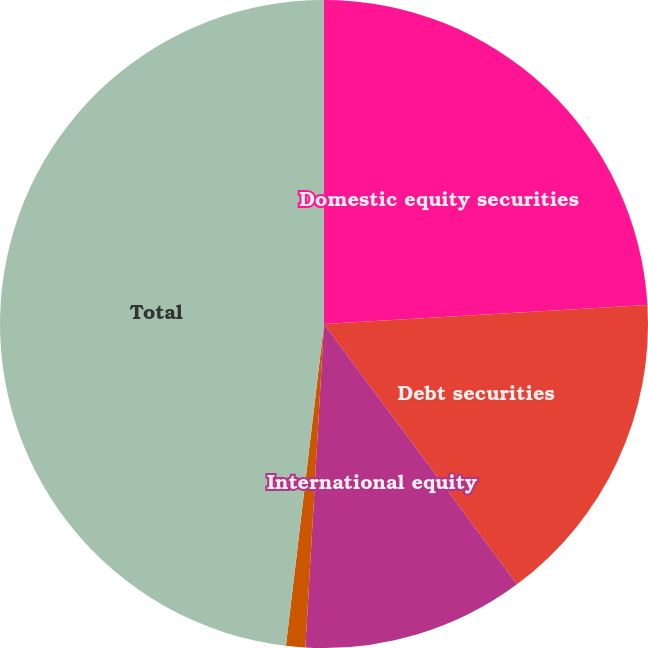<chart> <loc_0><loc_0><loc_500><loc_500><pie_chart><fcel>Domestic equity securities<fcel>Debt securities<fcel>International equity<fcel>Cash and cash equivalents<fcel>Total<nl><fcel>24.06%<fcel>15.78%<fcel>11.07%<fcel>0.96%<fcel>48.12%<nl></chart> 